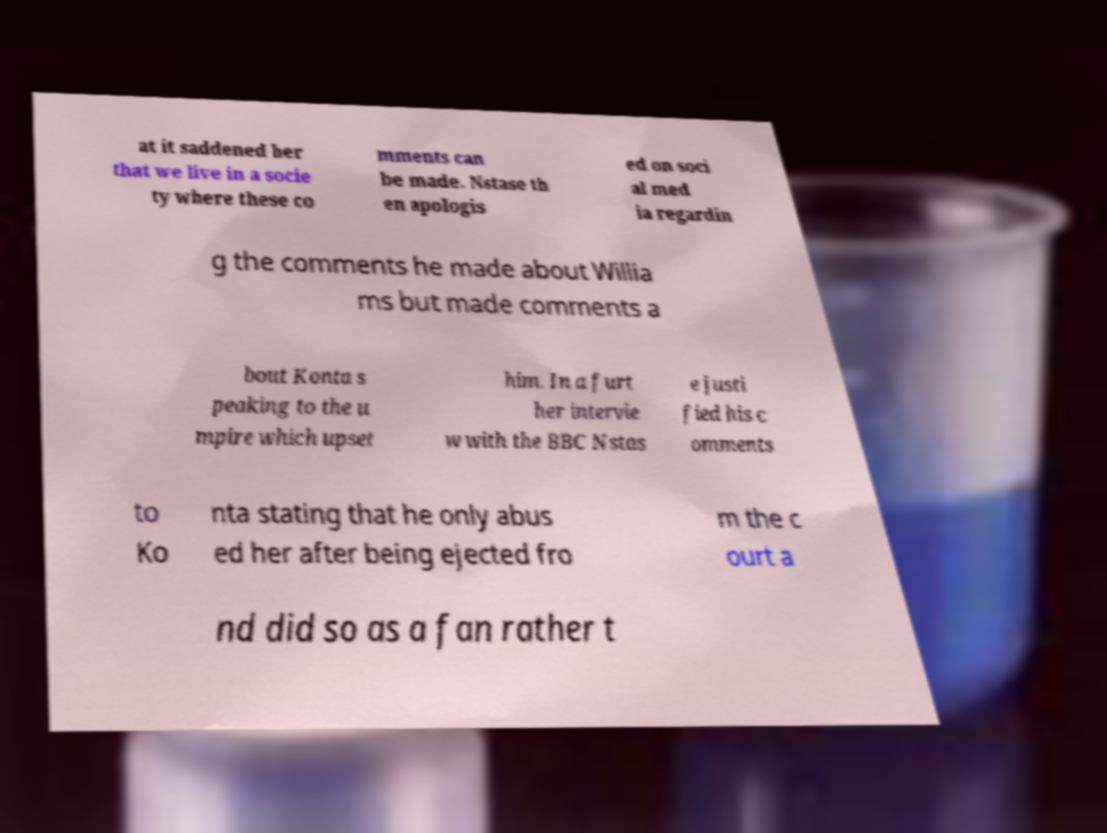Can you accurately transcribe the text from the provided image for me? at it saddened her that we live in a socie ty where these co mments can be made. Nstase th en apologis ed on soci al med ia regardin g the comments he made about Willia ms but made comments a bout Konta s peaking to the u mpire which upset him. In a furt her intervie w with the BBC Nstas e justi fied his c omments to Ko nta stating that he only abus ed her after being ejected fro m the c ourt a nd did so as a fan rather t 